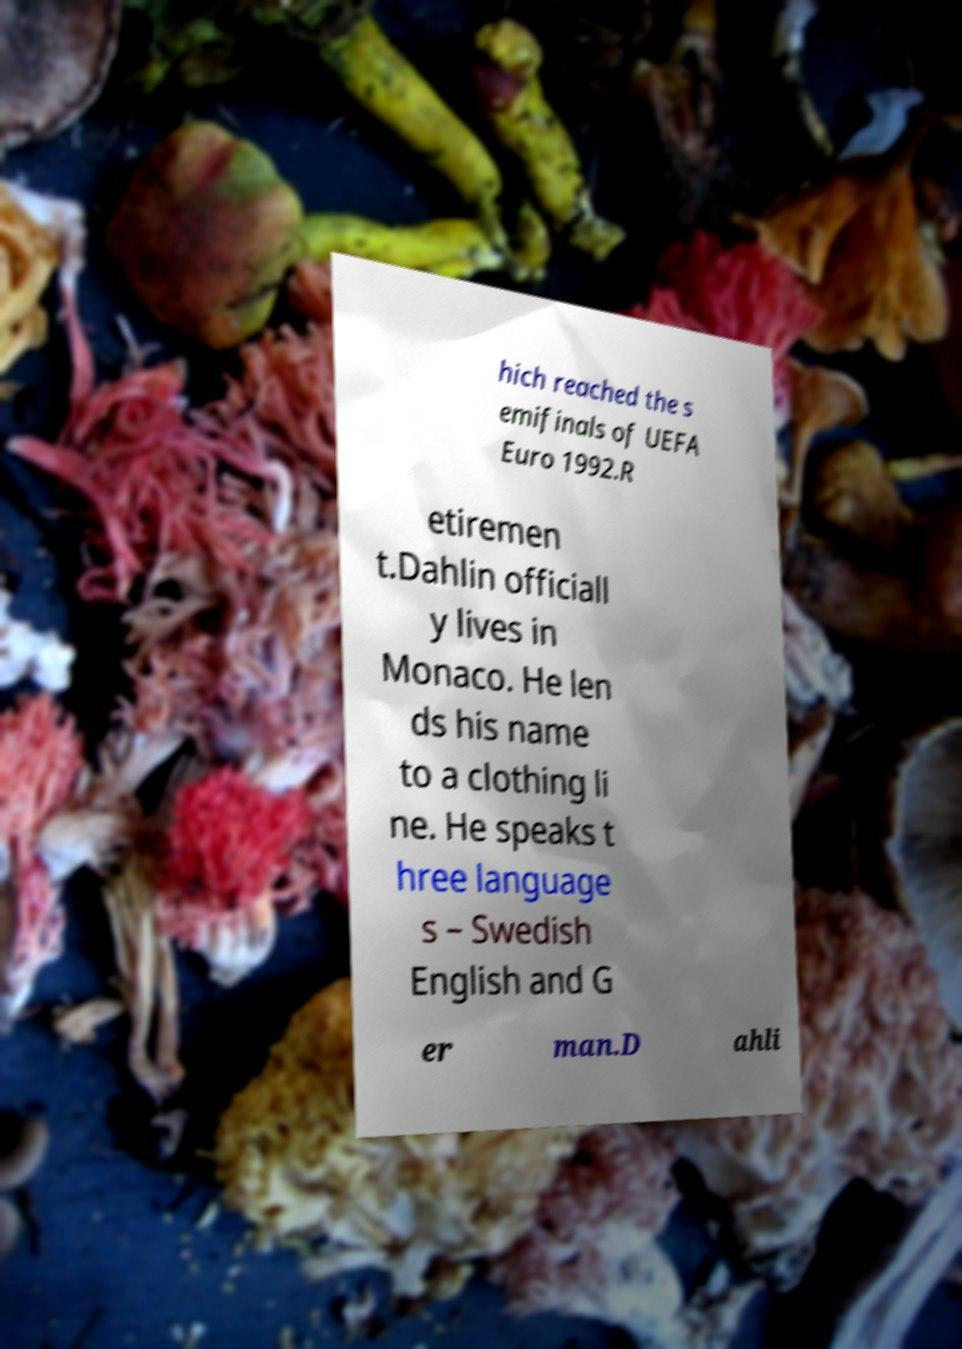Could you extract and type out the text from this image? hich reached the s emifinals of UEFA Euro 1992.R etiremen t.Dahlin officiall y lives in Monaco. He len ds his name to a clothing li ne. He speaks t hree language s – Swedish English and G er man.D ahli 